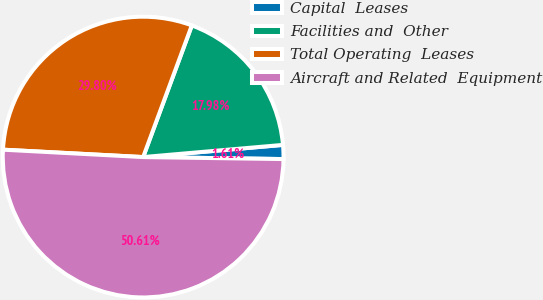Convert chart. <chart><loc_0><loc_0><loc_500><loc_500><pie_chart><fcel>Capital  Leases<fcel>Facilities and  Other<fcel>Total Operating  Leases<fcel>Aircraft and Related  Equipment<nl><fcel>1.61%<fcel>17.98%<fcel>29.8%<fcel>50.61%<nl></chart> 